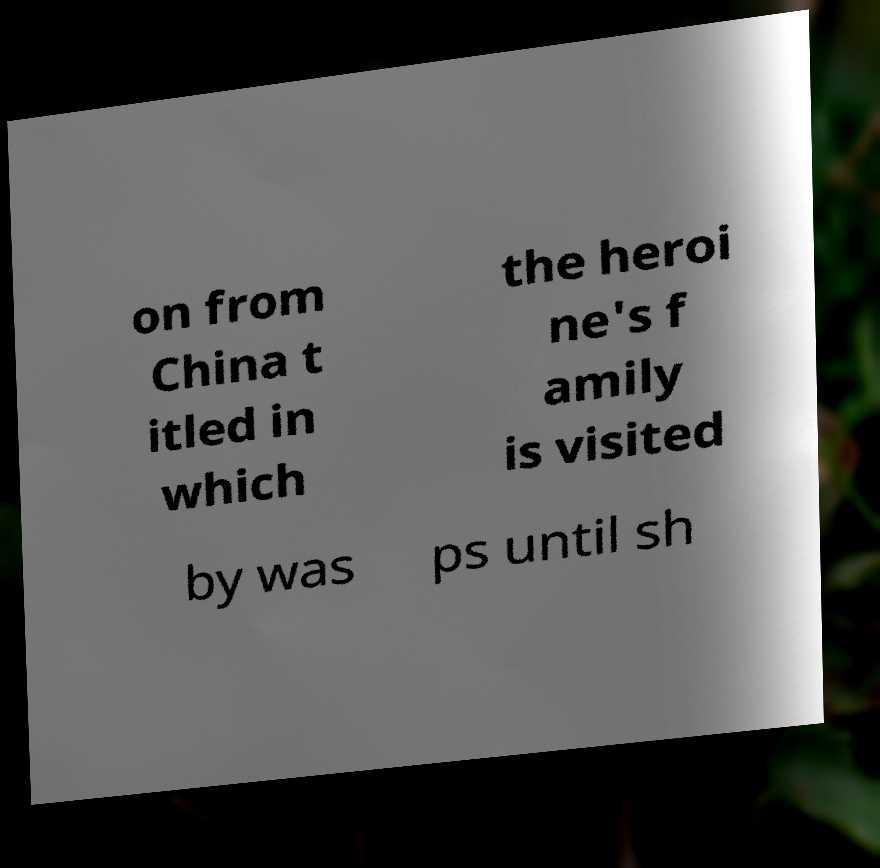Can you read and provide the text displayed in the image?This photo seems to have some interesting text. Can you extract and type it out for me? on from China t itled in which the heroi ne's f amily is visited by was ps until sh 